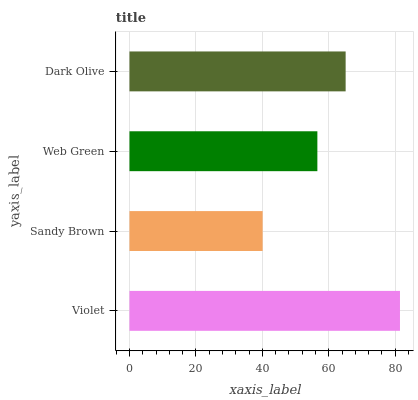Is Sandy Brown the minimum?
Answer yes or no. Yes. Is Violet the maximum?
Answer yes or no. Yes. Is Web Green the minimum?
Answer yes or no. No. Is Web Green the maximum?
Answer yes or no. No. Is Web Green greater than Sandy Brown?
Answer yes or no. Yes. Is Sandy Brown less than Web Green?
Answer yes or no. Yes. Is Sandy Brown greater than Web Green?
Answer yes or no. No. Is Web Green less than Sandy Brown?
Answer yes or no. No. Is Dark Olive the high median?
Answer yes or no. Yes. Is Web Green the low median?
Answer yes or no. Yes. Is Violet the high median?
Answer yes or no. No. Is Violet the low median?
Answer yes or no. No. 